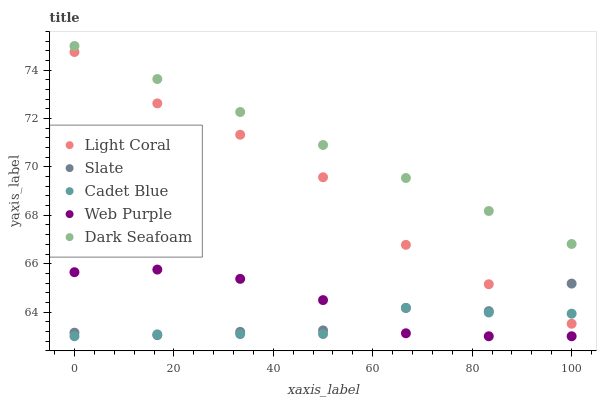Does Cadet Blue have the minimum area under the curve?
Answer yes or no. Yes. Does Dark Seafoam have the maximum area under the curve?
Answer yes or no. Yes. Does Slate have the minimum area under the curve?
Answer yes or no. No. Does Slate have the maximum area under the curve?
Answer yes or no. No. Is Dark Seafoam the smoothest?
Answer yes or no. Yes. Is Slate the roughest?
Answer yes or no. Yes. Is Cadet Blue the smoothest?
Answer yes or no. No. Is Cadet Blue the roughest?
Answer yes or no. No. Does Cadet Blue have the lowest value?
Answer yes or no. Yes. Does Slate have the lowest value?
Answer yes or no. No. Does Dark Seafoam have the highest value?
Answer yes or no. Yes. Does Slate have the highest value?
Answer yes or no. No. Is Light Coral less than Dark Seafoam?
Answer yes or no. Yes. Is Dark Seafoam greater than Cadet Blue?
Answer yes or no. Yes. Does Slate intersect Web Purple?
Answer yes or no. Yes. Is Slate less than Web Purple?
Answer yes or no. No. Is Slate greater than Web Purple?
Answer yes or no. No. Does Light Coral intersect Dark Seafoam?
Answer yes or no. No. 